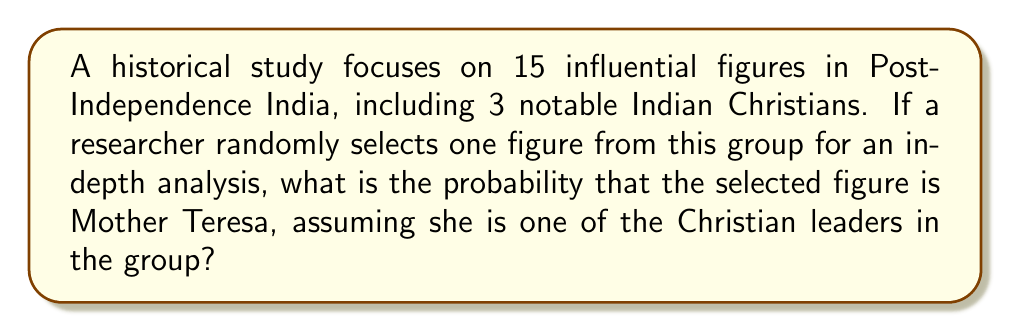Help me with this question. To solve this problem, we need to apply the concept of classical probability. The probability of an event is calculated by dividing the number of favorable outcomes by the total number of possible outcomes.

Let's break down the given information:
1. Total number of influential figures: 15
2. Number of notable Indian Christians: 3
3. Mother Teresa is one of the Christian leaders

Step 1: Identify the number of favorable outcomes.
In this case, we are only interested in selecting Mother Teresa, which is a single outcome.
Favorable outcomes = 1

Step 2: Identify the total number of possible outcomes.
The total number of possible outcomes is the total number of influential figures from which we can select.
Total possible outcomes = 15

Step 3: Apply the probability formula.
Probability = $\frac{\text{Number of favorable outcomes}}{\text{Total number of possible outcomes}}$

$$P(\text{selecting Mother Teresa}) = \frac{1}{15}$$

Step 4: Simplify the fraction (if needed).
In this case, the fraction $\frac{1}{15}$ is already in its simplest form.

Therefore, the probability of randomly selecting Mother Teresa from the group of influential figures is $\frac{1}{15}$.
Answer: $\frac{1}{15}$ 